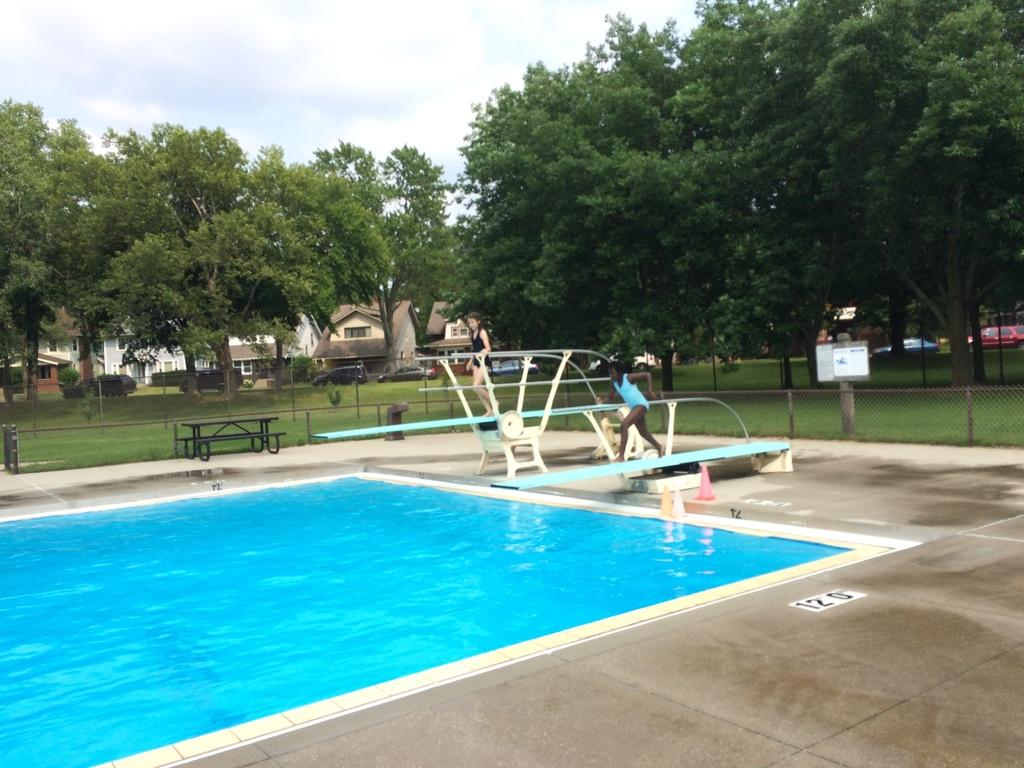Where was the image taken? The image is clicked outside. What can be seen in the image besides the woman running on the ramp? There is a swimming pool in the image. What is visible in the background of the image? There are trees and houses in the background of the image. Can you see any apples hanging from the trees in the image? There are no apples visible in the image; only trees and houses can be seen in the background. What type of thread is being used by the woman to run on the ramp? The image does not show any thread being used by the woman; she is running on a ramp without any visible support or assistance. 